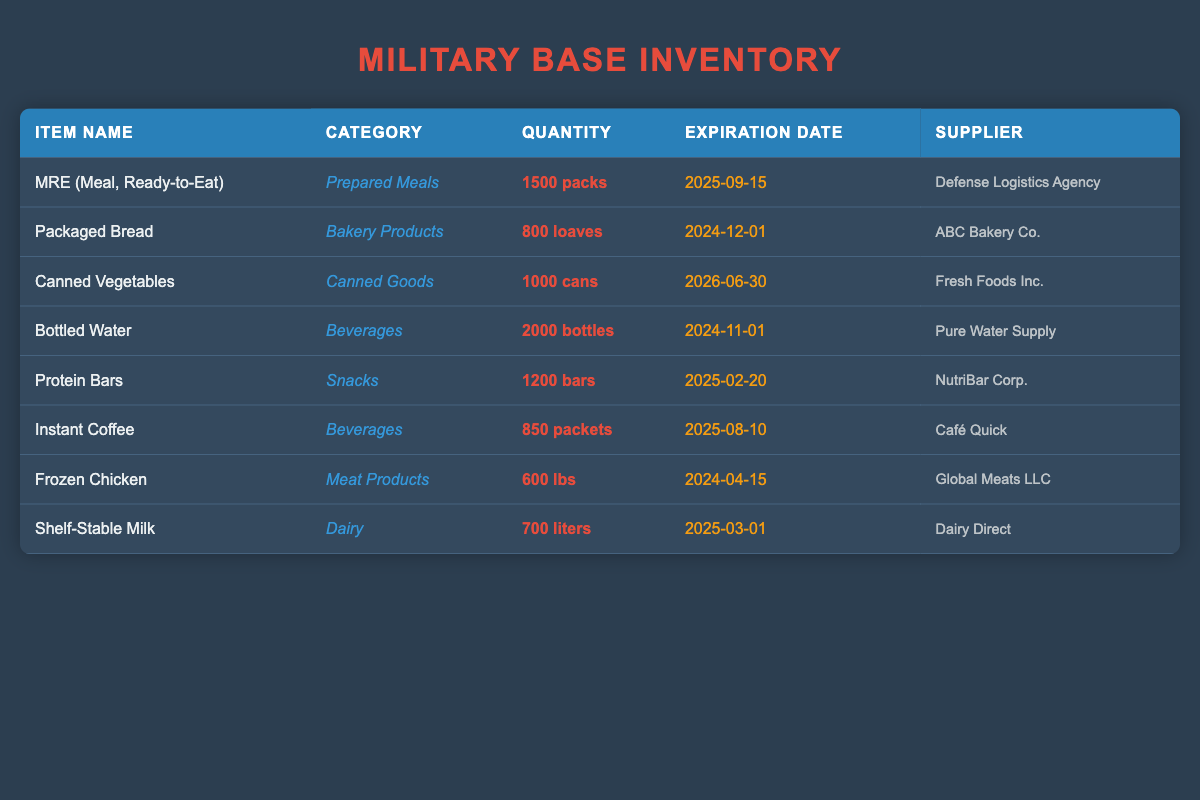What is the total quantity of Canned Vegetables? The table shows that there are 1000 cans of Canned Vegetables available.
Answer: 1000 cans Which item has the earliest expiration date? Looking through the expiration dates in the table: MRE on 2025-09-15, Packaged Bread on 2024-12-01, Canned Vegetables on 2026-06-30, Bottled Water on 2024-11-01, Protein Bars on 2025-02-20, Instant Coffee on 2025-08-10, Frozen Chicken on 2024-04-15, and Shelf-Stable Milk on 2025-03-01. The earliest is Bottled Water with an expiration date of 2024-11-01.
Answer: Bottled Water Is there more quantity of Bottled Water than Frozen Chicken? Comparing the quantities, Bottled Water has 2000 bottles, while Frozen Chicken has 600 lbs. Since 2000 is greater than 600, the statement is true.
Answer: Yes What is the total number of Prepared Meals and Snacks combined? The quantities for MRE (Prepared Meals) is 1500 packs and Protein Bars (Snacks) is 1200 bars. Adding them together gives 1500 + 1200 = 2700.
Answer: 2700 How many liters of Shelf-Stable Milk are available? The table indicates that there are 700 liters of Shelf-Stable Milk in inventory.
Answer: 700 liters Are there more types of beverages than bakery products listed in the table? The table lists two beverages: Bottled Water and Instant Coffee, and one bakery product: Packaged Bread. Since 2 > 1, the answer is yes.
Answer: Yes What is the difference in quantity between Protein Bars and Packaged Bread? The table shows that Protein Bars have 1200 bars and Packaged Bread has 800 loaves. The difference is calculated as 1200 - 800 = 400.
Answer: 400 If we add the quantity of all Meat Products, how many pounds will that be? The table lists Frozen Chicken under Meat Products, with a quantity of 600 lbs. Since it's the only item in this category, the total quantity will remain 600 lbs.
Answer: 600 lbs Which supplier provides the most items in the inventory? Analyzing the suppliers, Defense Logistics Agency provides MRE, ABC Bakery Co. provides Packaged Bread, Fresh Foods Inc. provides Canned Vegetables, Pure Water Supply provides Bottled Water, NutriBar Corp. provides Protein Bars, Café Quick provides Instant Coffee, Global Meats LLC provides Frozen Chicken, and Dairy Direct provides Shelf-Stable Milk. Each supplier corresponds to a single item; therefore, no supplier provides more than one item.
Answer: None 